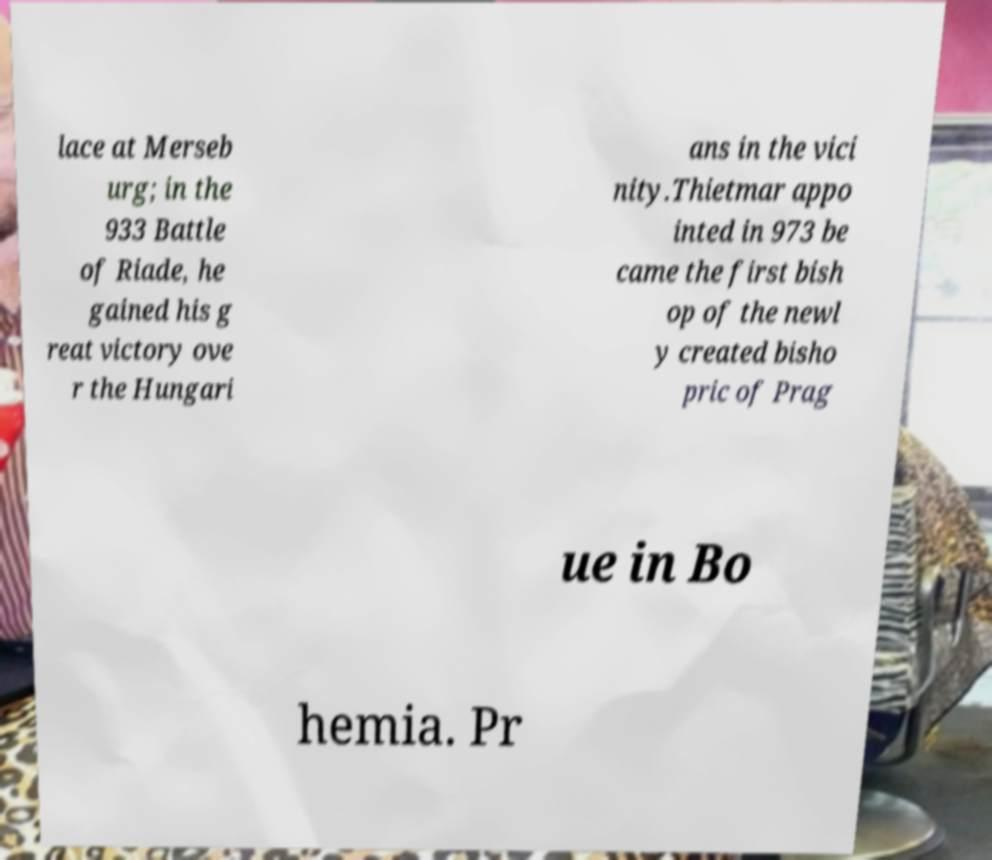Please identify and transcribe the text found in this image. lace at Merseb urg; in the 933 Battle of Riade, he gained his g reat victory ove r the Hungari ans in the vici nity.Thietmar appo inted in 973 be came the first bish op of the newl y created bisho pric of Prag ue in Bo hemia. Pr 